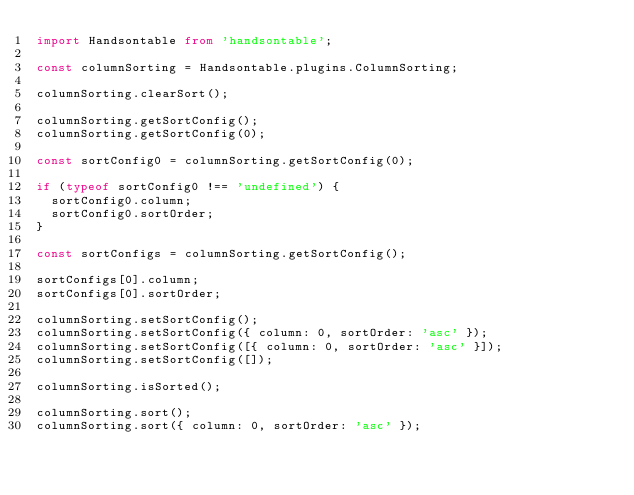<code> <loc_0><loc_0><loc_500><loc_500><_TypeScript_>import Handsontable from 'handsontable';

const columnSorting = Handsontable.plugins.ColumnSorting;

columnSorting.clearSort();

columnSorting.getSortConfig();
columnSorting.getSortConfig(0);

const sortConfig0 = columnSorting.getSortConfig(0);

if (typeof sortConfig0 !== 'undefined') {
  sortConfig0.column;
  sortConfig0.sortOrder;
}

const sortConfigs = columnSorting.getSortConfig();

sortConfigs[0].column;
sortConfigs[0].sortOrder;

columnSorting.setSortConfig();
columnSorting.setSortConfig({ column: 0, sortOrder: 'asc' });
columnSorting.setSortConfig([{ column: 0, sortOrder: 'asc' }]);
columnSorting.setSortConfig([]);

columnSorting.isSorted();

columnSorting.sort();
columnSorting.sort({ column: 0, sortOrder: 'asc' });
</code> 